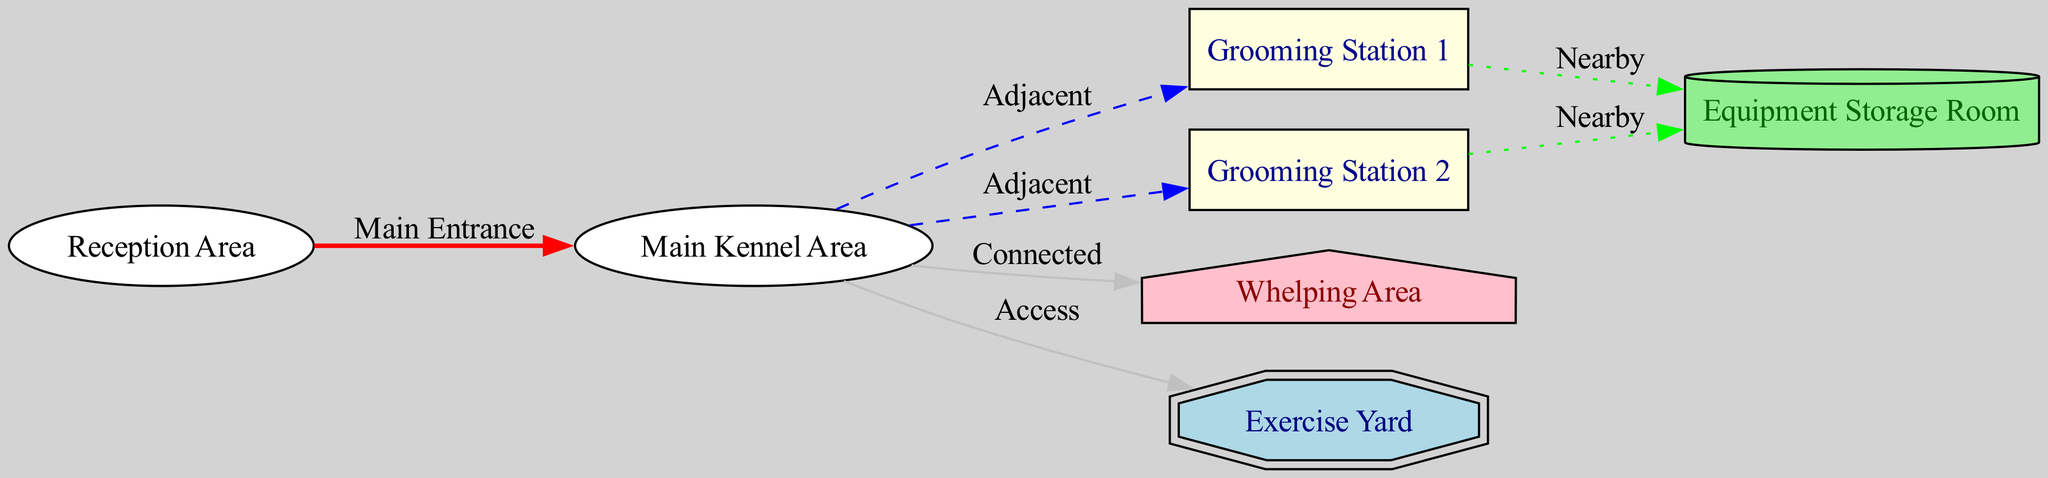What is the label of the first grooming station? The first grooming station in the diagram is labeled "Grooming Station 1," which is indicated by its node ID and label in the nodes section of the data.
Answer: Grooming Station 1 How many grooming stations are designated in the kennel layout? The diagram mentions two grooming stations: "Grooming Station 1" and "Grooming Station 2," which can be identified by counting the nodes labeled as grooming stations in the data.
Answer: 2 What is the relationship between the main kennel area and the whelping area? The relationship is labeled as "Connected" in the edges section of the data, indicating a direct link between these two nodes.
Answer: Connected Which area is labeled as "Equipment Storage Room"? The node with the ID "equipment_storage" is clearly labeled as "Equipment Storage Room," as indicated in the node list of the diagram data.
Answer: Equipment Storage Room What type of area is the "Exercise Yard"? The "Exercise Yard" is represented as a double octagon shape in the diagram, which is noted in the node's description within the data provided.
Answer: Exercise Yard Which grooming station is nearest to the equipment storage room? Both grooming stations (Grooming Station 1 and 2) have a "Nearby" connection to the equipment storage room, as indicated by their respective edges in the diagram. Therefore, they both can be considered equally near.
Answer: Both stations What entrance is used to access the main kennel area from the reception area? The access is labeled as "Main Entrance" according to the edge that connects the reception area to the main kennel area in the diagram, which specifies the type of entrance.
Answer: Main Entrance How many total nodes are present in the breeding kennel layout diagram? The total nodes listed in the data segment amounts to 6, which can be counted directly from the nodes section.
Answer: 6 Is there a direct connection from the equipment storage to any grooming station? There is no direct edge from the equipment storage room to any grooming station mentioned in the edges list; the connections are merely "Nearby." Therefore, the equipment storage does not connect directly.
Answer: No 